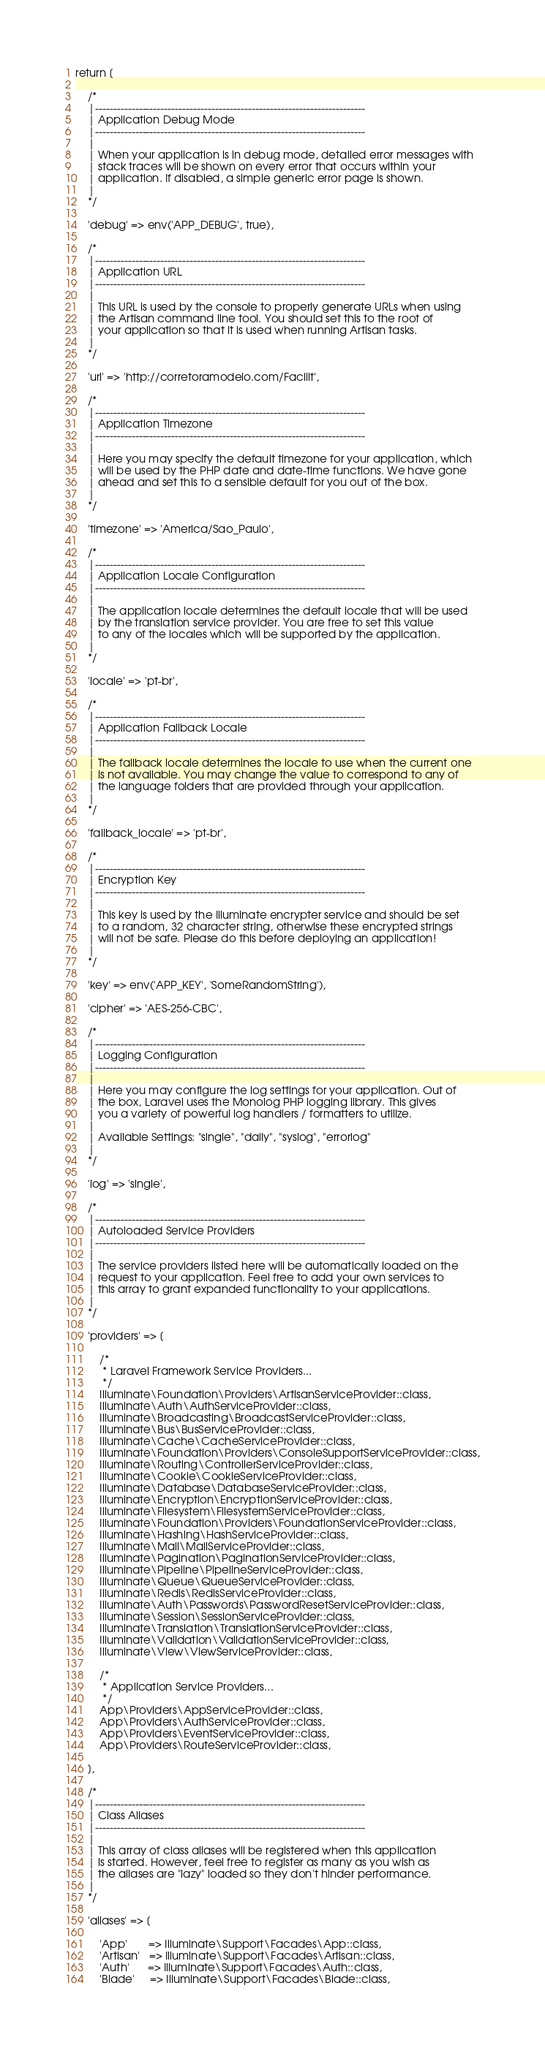<code> <loc_0><loc_0><loc_500><loc_500><_PHP_>return [

    /*
    |--------------------------------------------------------------------------
    | Application Debug Mode
    |--------------------------------------------------------------------------
    |
    | When your application is in debug mode, detailed error messages with
    | stack traces will be shown on every error that occurs within your
    | application. If disabled, a simple generic error page is shown.
    |
    */

    'debug' => env('APP_DEBUG', true),

    /*
    |--------------------------------------------------------------------------
    | Application URL
    |--------------------------------------------------------------------------
    |
    | This URL is used by the console to properly generate URLs when using
    | the Artisan command line tool. You should set this to the root of
    | your application so that it is used when running Artisan tasks.
    |
    */

    'url' => 'http://corretoramodelo.com/Facilit',

    /*
    |--------------------------------------------------------------------------
    | Application Timezone
    |--------------------------------------------------------------------------
    |
    | Here you may specify the default timezone for your application, which
    | will be used by the PHP date and date-time functions. We have gone
    | ahead and set this to a sensible default for you out of the box.
    |
    */

    'timezone' => 'America/Sao_Paulo',

    /*
    |--------------------------------------------------------------------------
    | Application Locale Configuration
    |--------------------------------------------------------------------------
    |
    | The application locale determines the default locale that will be used
    | by the translation service provider. You are free to set this value
    | to any of the locales which will be supported by the application.
    |
    */

    'locale' => 'pt-br',

    /*
    |--------------------------------------------------------------------------
    | Application Fallback Locale
    |--------------------------------------------------------------------------
    |
    | The fallback locale determines the locale to use when the current one
    | is not available. You may change the value to correspond to any of
    | the language folders that are provided through your application.
    |
    */

    'fallback_locale' => 'pt-br',

    /*
    |--------------------------------------------------------------------------
    | Encryption Key
    |--------------------------------------------------------------------------
    |
    | This key is used by the Illuminate encrypter service and should be set
    | to a random, 32 character string, otherwise these encrypted strings
    | will not be safe. Please do this before deploying an application!
    |
    */

    'key' => env('APP_KEY', 'SomeRandomString'),

    'cipher' => 'AES-256-CBC',

    /*
    |--------------------------------------------------------------------------
    | Logging Configuration
    |--------------------------------------------------------------------------
    |
    | Here you may configure the log settings for your application. Out of
    | the box, Laravel uses the Monolog PHP logging library. This gives
    | you a variety of powerful log handlers / formatters to utilize.
    |
    | Available Settings: "single", "daily", "syslog", "errorlog"
    |
    */

    'log' => 'single',

    /*
    |--------------------------------------------------------------------------
    | Autoloaded Service Providers
    |--------------------------------------------------------------------------
    |
    | The service providers listed here will be automatically loaded on the
    | request to your application. Feel free to add your own services to
    | this array to grant expanded functionality to your applications.
    |
    */

    'providers' => [

        /*
         * Laravel Framework Service Providers...
         */
        Illuminate\Foundation\Providers\ArtisanServiceProvider::class,
        Illuminate\Auth\AuthServiceProvider::class,
        Illuminate\Broadcasting\BroadcastServiceProvider::class,
        Illuminate\Bus\BusServiceProvider::class,
        Illuminate\Cache\CacheServiceProvider::class,
        Illuminate\Foundation\Providers\ConsoleSupportServiceProvider::class,
        Illuminate\Routing\ControllerServiceProvider::class,
        Illuminate\Cookie\CookieServiceProvider::class,
        Illuminate\Database\DatabaseServiceProvider::class,
        Illuminate\Encryption\EncryptionServiceProvider::class,
        Illuminate\Filesystem\FilesystemServiceProvider::class,
        Illuminate\Foundation\Providers\FoundationServiceProvider::class,
        Illuminate\Hashing\HashServiceProvider::class,
        Illuminate\Mail\MailServiceProvider::class,
        Illuminate\Pagination\PaginationServiceProvider::class,
        Illuminate\Pipeline\PipelineServiceProvider::class,
        Illuminate\Queue\QueueServiceProvider::class,
        Illuminate\Redis\RedisServiceProvider::class,
        Illuminate\Auth\Passwords\PasswordResetServiceProvider::class,
        Illuminate\Session\SessionServiceProvider::class,
        Illuminate\Translation\TranslationServiceProvider::class,
        Illuminate\Validation\ValidationServiceProvider::class,
        Illuminate\View\ViewServiceProvider::class,

        /*
         * Application Service Providers...
         */
        App\Providers\AppServiceProvider::class,
        App\Providers\AuthServiceProvider::class,
        App\Providers\EventServiceProvider::class,
        App\Providers\RouteServiceProvider::class,

    ],

    /*
    |--------------------------------------------------------------------------
    | Class Aliases
    |--------------------------------------------------------------------------
    |
    | This array of class aliases will be registered when this application
    | is started. However, feel free to register as many as you wish as
    | the aliases are "lazy" loaded so they don't hinder performance.
    |
    */

    'aliases' => [

        'App'       => Illuminate\Support\Facades\App::class,
        'Artisan'   => Illuminate\Support\Facades\Artisan::class,
        'Auth'      => Illuminate\Support\Facades\Auth::class,
        'Blade'     => Illuminate\Support\Facades\Blade::class,</code> 